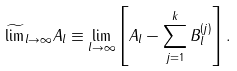Convert formula to latex. <formula><loc_0><loc_0><loc_500><loc_500>\widetilde { \lim } _ { l \to \infty } A _ { l } \equiv \lim _ { l \to \infty } \left [ A _ { l } - \sum _ { j = 1 } ^ { k } B _ { l } ^ { ( j ) } \right ] .</formula> 